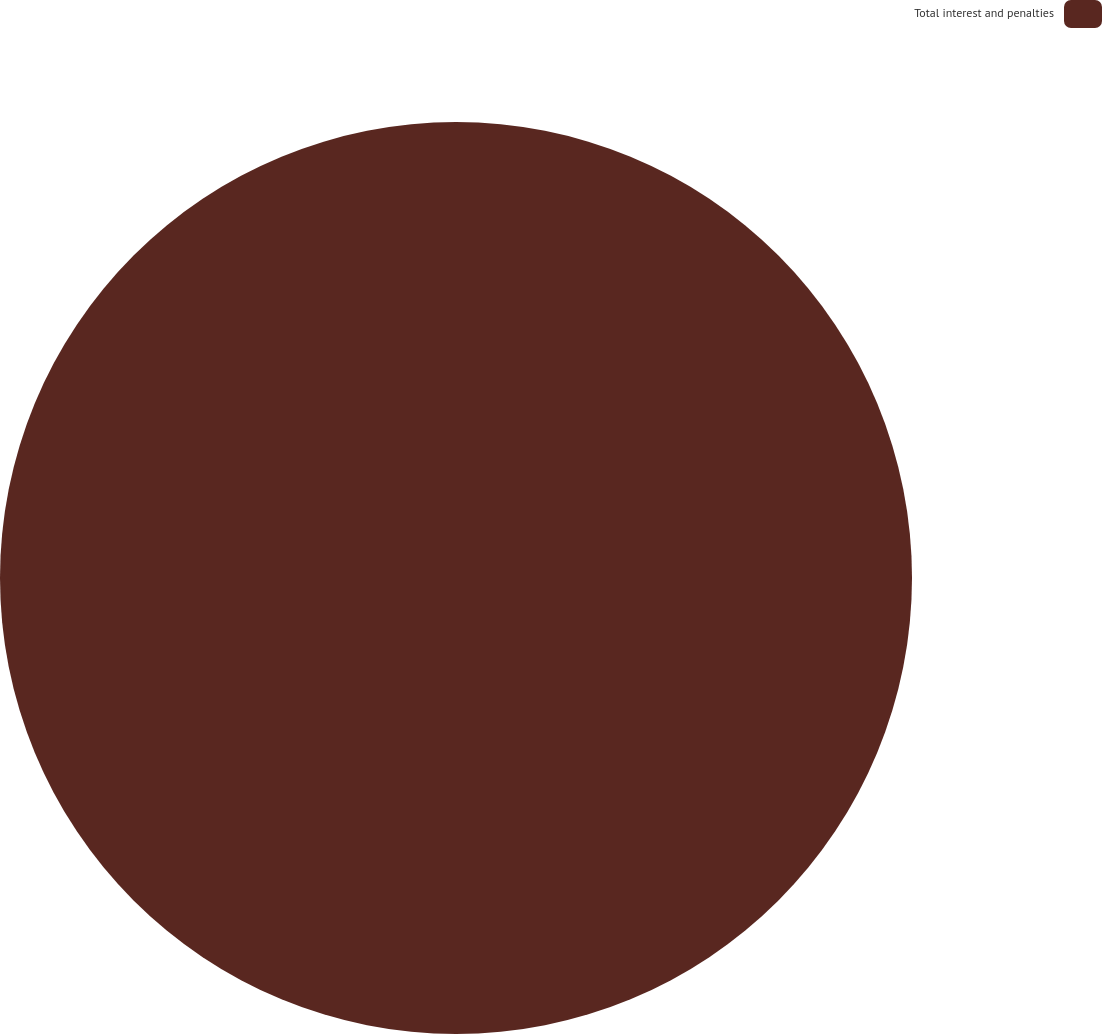<chart> <loc_0><loc_0><loc_500><loc_500><pie_chart><fcel>Total interest and penalties<nl><fcel>100.0%<nl></chart> 